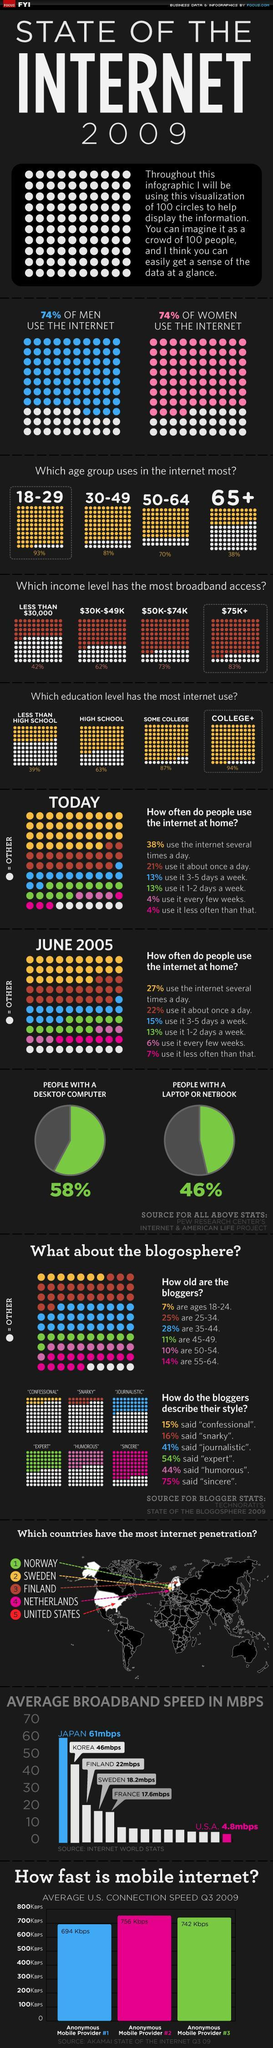Which age group uses internet the least?
Answer the question with a short phrase. 65+ In which position does USA come in the average broadband speed of countries graph? 15 Which income level had most broadband access? $75K+ What percentage of people do not own a desktop? 42% In the below 30,000 income group, how many have broadband access? 42% What percentage of 18-29 year olds use the internet? 93% Which country has the third highest broadband speed? Finland The number of men using the internet compared to women is - higher, lower or equal? equal In which age group is the percentage of internet users 81%? 30-49 